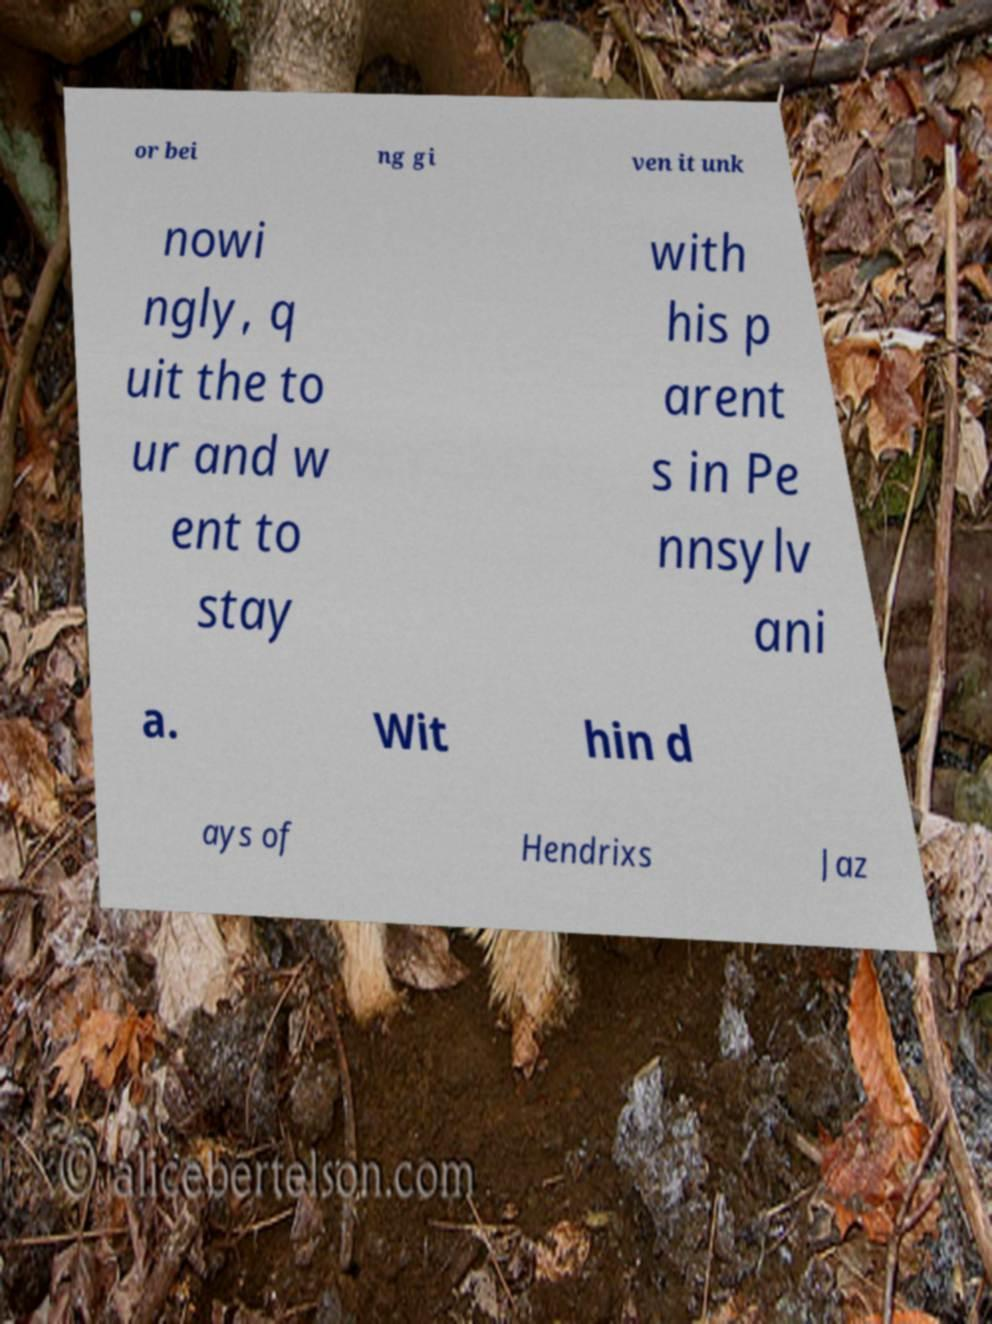For documentation purposes, I need the text within this image transcribed. Could you provide that? or bei ng gi ven it unk nowi ngly, q uit the to ur and w ent to stay with his p arent s in Pe nnsylv ani a. Wit hin d ays of Hendrixs Jaz 